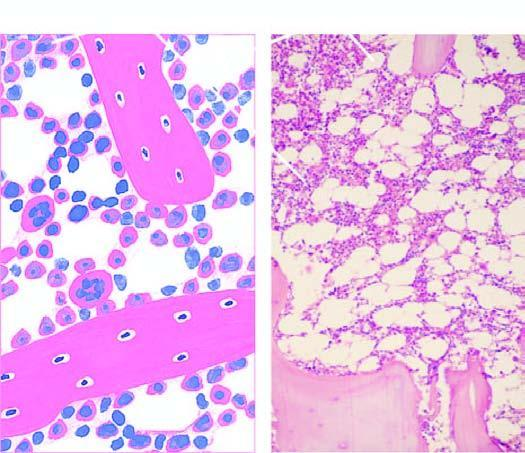when is a normal bone marrow in an adult seen seen in a section?
Answer the question using a single word or phrase. After trephine biopsy 